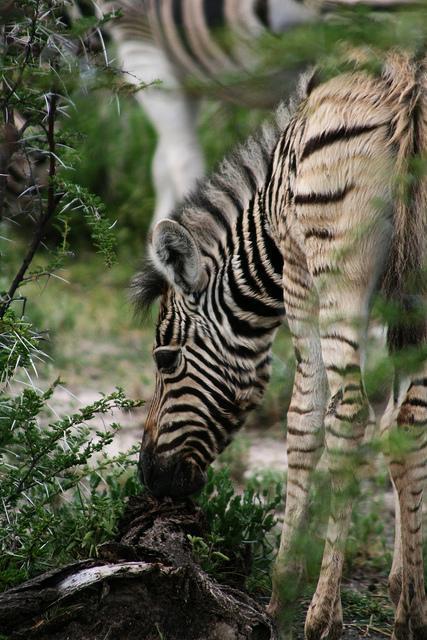How many zebras are there?
Give a very brief answer. 2. 